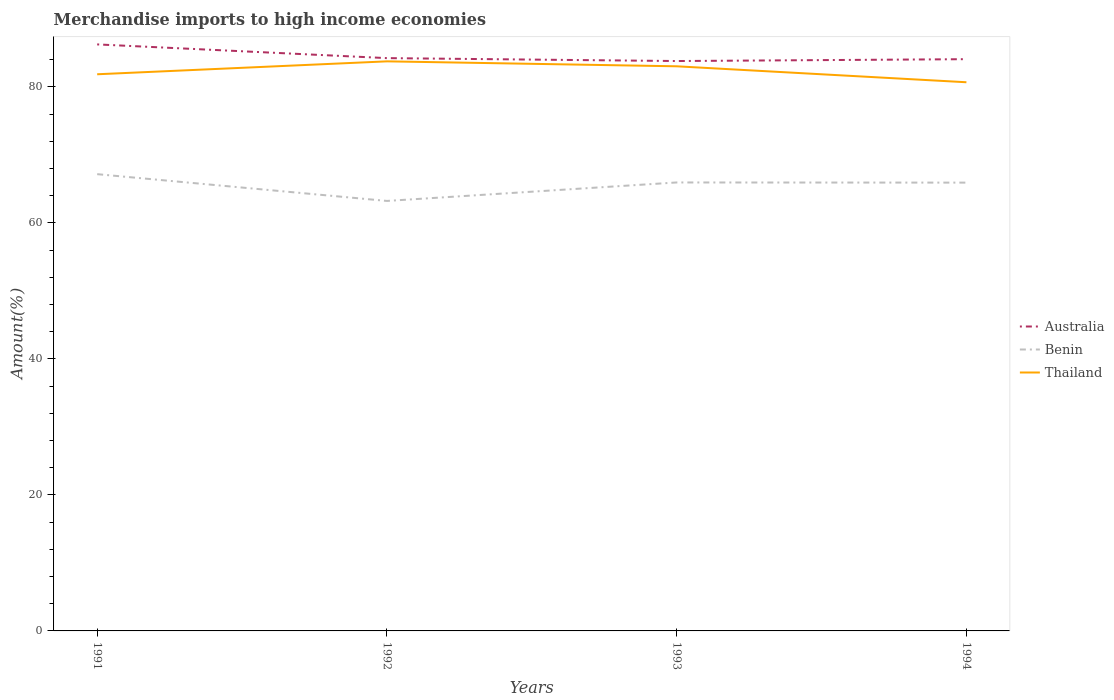How many different coloured lines are there?
Keep it short and to the point. 3. Does the line corresponding to Benin intersect with the line corresponding to Australia?
Provide a succinct answer. No. Is the number of lines equal to the number of legend labels?
Your response must be concise. Yes. Across all years, what is the maximum percentage of amount earned from merchandise imports in Australia?
Give a very brief answer. 83.79. What is the total percentage of amount earned from merchandise imports in Thailand in the graph?
Your answer should be very brief. -1.9. What is the difference between the highest and the second highest percentage of amount earned from merchandise imports in Australia?
Provide a short and direct response. 2.45. What is the difference between the highest and the lowest percentage of amount earned from merchandise imports in Australia?
Offer a terse response. 1. Is the percentage of amount earned from merchandise imports in Benin strictly greater than the percentage of amount earned from merchandise imports in Australia over the years?
Your answer should be very brief. Yes. What is the difference between two consecutive major ticks on the Y-axis?
Your answer should be very brief. 20. Are the values on the major ticks of Y-axis written in scientific E-notation?
Give a very brief answer. No. Does the graph contain any zero values?
Your answer should be very brief. No. Does the graph contain grids?
Offer a terse response. No. How are the legend labels stacked?
Provide a short and direct response. Vertical. What is the title of the graph?
Give a very brief answer. Merchandise imports to high income economies. Does "Heavily indebted poor countries" appear as one of the legend labels in the graph?
Provide a succinct answer. No. What is the label or title of the X-axis?
Your answer should be compact. Years. What is the label or title of the Y-axis?
Give a very brief answer. Amount(%). What is the Amount(%) of Australia in 1991?
Ensure brevity in your answer.  86.24. What is the Amount(%) in Benin in 1991?
Your response must be concise. 67.16. What is the Amount(%) of Thailand in 1991?
Your response must be concise. 81.85. What is the Amount(%) of Australia in 1992?
Offer a very short reply. 84.22. What is the Amount(%) in Benin in 1992?
Provide a short and direct response. 63.22. What is the Amount(%) of Thailand in 1992?
Give a very brief answer. 83.75. What is the Amount(%) in Australia in 1993?
Offer a terse response. 83.79. What is the Amount(%) of Benin in 1993?
Offer a very short reply. 65.94. What is the Amount(%) of Thailand in 1993?
Your answer should be very brief. 83.02. What is the Amount(%) in Australia in 1994?
Offer a terse response. 84.07. What is the Amount(%) of Benin in 1994?
Provide a short and direct response. 65.92. What is the Amount(%) of Thailand in 1994?
Make the answer very short. 80.68. Across all years, what is the maximum Amount(%) of Australia?
Your answer should be very brief. 86.24. Across all years, what is the maximum Amount(%) in Benin?
Offer a terse response. 67.16. Across all years, what is the maximum Amount(%) in Thailand?
Your response must be concise. 83.75. Across all years, what is the minimum Amount(%) of Australia?
Keep it short and to the point. 83.79. Across all years, what is the minimum Amount(%) in Benin?
Offer a very short reply. 63.22. Across all years, what is the minimum Amount(%) of Thailand?
Your answer should be compact. 80.68. What is the total Amount(%) in Australia in the graph?
Provide a short and direct response. 338.33. What is the total Amount(%) in Benin in the graph?
Offer a terse response. 262.24. What is the total Amount(%) of Thailand in the graph?
Offer a terse response. 329.29. What is the difference between the Amount(%) of Australia in 1991 and that in 1992?
Give a very brief answer. 2.02. What is the difference between the Amount(%) of Benin in 1991 and that in 1992?
Make the answer very short. 3.94. What is the difference between the Amount(%) of Thailand in 1991 and that in 1992?
Provide a succinct answer. -1.9. What is the difference between the Amount(%) of Australia in 1991 and that in 1993?
Offer a very short reply. 2.45. What is the difference between the Amount(%) of Benin in 1991 and that in 1993?
Offer a very short reply. 1.22. What is the difference between the Amount(%) in Thailand in 1991 and that in 1993?
Provide a succinct answer. -1.17. What is the difference between the Amount(%) of Australia in 1991 and that in 1994?
Offer a very short reply. 2.17. What is the difference between the Amount(%) in Benin in 1991 and that in 1994?
Ensure brevity in your answer.  1.24. What is the difference between the Amount(%) of Thailand in 1991 and that in 1994?
Your answer should be compact. 1.17. What is the difference between the Amount(%) of Australia in 1992 and that in 1993?
Provide a succinct answer. 0.43. What is the difference between the Amount(%) of Benin in 1992 and that in 1993?
Your response must be concise. -2.72. What is the difference between the Amount(%) in Thailand in 1992 and that in 1993?
Your response must be concise. 0.73. What is the difference between the Amount(%) in Australia in 1992 and that in 1994?
Your answer should be compact. 0.15. What is the difference between the Amount(%) in Benin in 1992 and that in 1994?
Offer a very short reply. -2.69. What is the difference between the Amount(%) of Thailand in 1992 and that in 1994?
Your answer should be compact. 3.07. What is the difference between the Amount(%) of Australia in 1993 and that in 1994?
Offer a very short reply. -0.27. What is the difference between the Amount(%) of Benin in 1993 and that in 1994?
Provide a short and direct response. 0.02. What is the difference between the Amount(%) in Thailand in 1993 and that in 1994?
Offer a terse response. 2.34. What is the difference between the Amount(%) in Australia in 1991 and the Amount(%) in Benin in 1992?
Provide a succinct answer. 23.02. What is the difference between the Amount(%) of Australia in 1991 and the Amount(%) of Thailand in 1992?
Make the answer very short. 2.49. What is the difference between the Amount(%) of Benin in 1991 and the Amount(%) of Thailand in 1992?
Your answer should be compact. -16.59. What is the difference between the Amount(%) in Australia in 1991 and the Amount(%) in Benin in 1993?
Your answer should be compact. 20.3. What is the difference between the Amount(%) in Australia in 1991 and the Amount(%) in Thailand in 1993?
Provide a succinct answer. 3.22. What is the difference between the Amount(%) of Benin in 1991 and the Amount(%) of Thailand in 1993?
Your response must be concise. -15.86. What is the difference between the Amount(%) of Australia in 1991 and the Amount(%) of Benin in 1994?
Give a very brief answer. 20.32. What is the difference between the Amount(%) in Australia in 1991 and the Amount(%) in Thailand in 1994?
Ensure brevity in your answer.  5.56. What is the difference between the Amount(%) of Benin in 1991 and the Amount(%) of Thailand in 1994?
Make the answer very short. -13.51. What is the difference between the Amount(%) of Australia in 1992 and the Amount(%) of Benin in 1993?
Provide a short and direct response. 18.28. What is the difference between the Amount(%) of Australia in 1992 and the Amount(%) of Thailand in 1993?
Provide a short and direct response. 1.2. What is the difference between the Amount(%) of Benin in 1992 and the Amount(%) of Thailand in 1993?
Provide a succinct answer. -19.8. What is the difference between the Amount(%) of Australia in 1992 and the Amount(%) of Benin in 1994?
Offer a terse response. 18.31. What is the difference between the Amount(%) of Australia in 1992 and the Amount(%) of Thailand in 1994?
Keep it short and to the point. 3.55. What is the difference between the Amount(%) of Benin in 1992 and the Amount(%) of Thailand in 1994?
Offer a terse response. -17.45. What is the difference between the Amount(%) of Australia in 1993 and the Amount(%) of Benin in 1994?
Ensure brevity in your answer.  17.88. What is the difference between the Amount(%) in Australia in 1993 and the Amount(%) in Thailand in 1994?
Give a very brief answer. 3.12. What is the difference between the Amount(%) in Benin in 1993 and the Amount(%) in Thailand in 1994?
Your response must be concise. -14.73. What is the average Amount(%) in Australia per year?
Provide a short and direct response. 84.58. What is the average Amount(%) of Benin per year?
Offer a terse response. 65.56. What is the average Amount(%) of Thailand per year?
Ensure brevity in your answer.  82.32. In the year 1991, what is the difference between the Amount(%) in Australia and Amount(%) in Benin?
Offer a terse response. 19.08. In the year 1991, what is the difference between the Amount(%) in Australia and Amount(%) in Thailand?
Offer a very short reply. 4.39. In the year 1991, what is the difference between the Amount(%) of Benin and Amount(%) of Thailand?
Offer a very short reply. -14.69. In the year 1992, what is the difference between the Amount(%) of Australia and Amount(%) of Benin?
Your response must be concise. 21. In the year 1992, what is the difference between the Amount(%) of Australia and Amount(%) of Thailand?
Your answer should be compact. 0.47. In the year 1992, what is the difference between the Amount(%) in Benin and Amount(%) in Thailand?
Your answer should be very brief. -20.52. In the year 1993, what is the difference between the Amount(%) in Australia and Amount(%) in Benin?
Keep it short and to the point. 17.85. In the year 1993, what is the difference between the Amount(%) of Australia and Amount(%) of Thailand?
Keep it short and to the point. 0.77. In the year 1993, what is the difference between the Amount(%) in Benin and Amount(%) in Thailand?
Provide a short and direct response. -17.08. In the year 1994, what is the difference between the Amount(%) of Australia and Amount(%) of Benin?
Offer a very short reply. 18.15. In the year 1994, what is the difference between the Amount(%) of Australia and Amount(%) of Thailand?
Give a very brief answer. 3.39. In the year 1994, what is the difference between the Amount(%) of Benin and Amount(%) of Thailand?
Make the answer very short. -14.76. What is the ratio of the Amount(%) of Australia in 1991 to that in 1992?
Offer a terse response. 1.02. What is the ratio of the Amount(%) in Benin in 1991 to that in 1992?
Your response must be concise. 1.06. What is the ratio of the Amount(%) of Thailand in 1991 to that in 1992?
Make the answer very short. 0.98. What is the ratio of the Amount(%) in Australia in 1991 to that in 1993?
Offer a terse response. 1.03. What is the ratio of the Amount(%) of Benin in 1991 to that in 1993?
Keep it short and to the point. 1.02. What is the ratio of the Amount(%) of Thailand in 1991 to that in 1993?
Keep it short and to the point. 0.99. What is the ratio of the Amount(%) of Australia in 1991 to that in 1994?
Make the answer very short. 1.03. What is the ratio of the Amount(%) of Benin in 1991 to that in 1994?
Offer a terse response. 1.02. What is the ratio of the Amount(%) of Thailand in 1991 to that in 1994?
Your answer should be very brief. 1.01. What is the ratio of the Amount(%) of Australia in 1992 to that in 1993?
Offer a terse response. 1.01. What is the ratio of the Amount(%) of Benin in 1992 to that in 1993?
Give a very brief answer. 0.96. What is the ratio of the Amount(%) of Thailand in 1992 to that in 1993?
Keep it short and to the point. 1.01. What is the ratio of the Amount(%) in Benin in 1992 to that in 1994?
Your answer should be very brief. 0.96. What is the ratio of the Amount(%) in Thailand in 1992 to that in 1994?
Ensure brevity in your answer.  1.04. What is the ratio of the Amount(%) of Thailand in 1993 to that in 1994?
Make the answer very short. 1.03. What is the difference between the highest and the second highest Amount(%) in Australia?
Make the answer very short. 2.02. What is the difference between the highest and the second highest Amount(%) in Benin?
Provide a short and direct response. 1.22. What is the difference between the highest and the second highest Amount(%) of Thailand?
Your response must be concise. 0.73. What is the difference between the highest and the lowest Amount(%) in Australia?
Your answer should be very brief. 2.45. What is the difference between the highest and the lowest Amount(%) in Benin?
Provide a succinct answer. 3.94. What is the difference between the highest and the lowest Amount(%) in Thailand?
Ensure brevity in your answer.  3.07. 